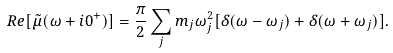Convert formula to latex. <formula><loc_0><loc_0><loc_500><loc_500>R e [ \tilde { \mu } ( \omega + i 0 ^ { + } ) ] = \frac { \pi } { 2 } \sum _ { j } m _ { j } \omega ^ { 2 } _ { j } [ \delta ( \omega - \omega _ { j } ) + \delta ( \omega + \omega _ { j } ) ] .</formula> 